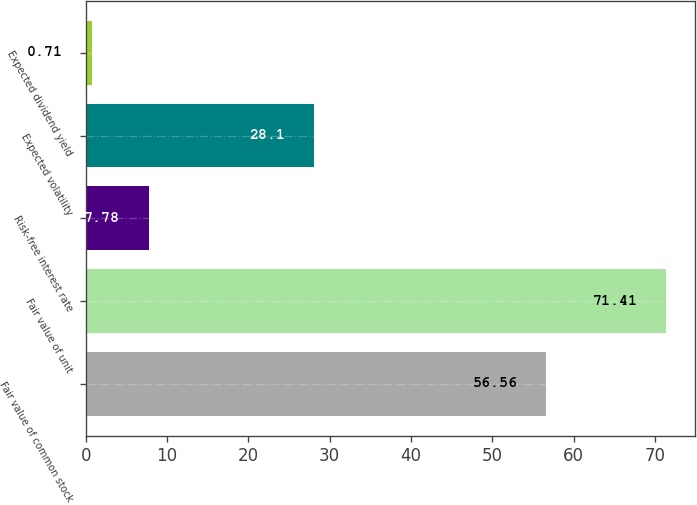<chart> <loc_0><loc_0><loc_500><loc_500><bar_chart><fcel>Fair value of common stock<fcel>Fair value of unit<fcel>Risk-free interest rate<fcel>Expected volatility<fcel>Expected dividend yield<nl><fcel>56.56<fcel>71.41<fcel>7.78<fcel>28.1<fcel>0.71<nl></chart> 